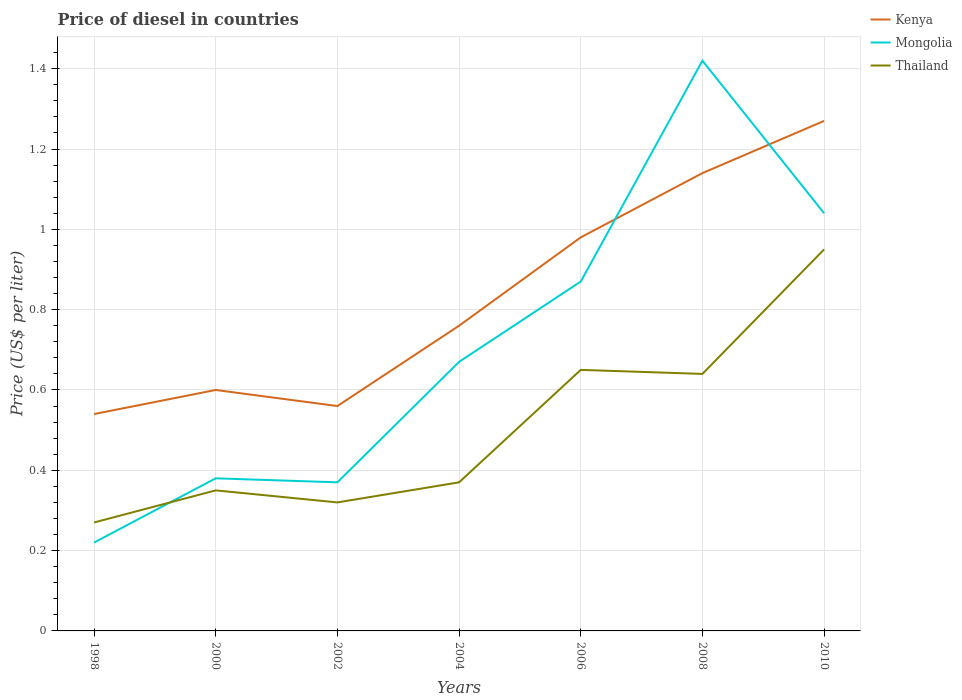How many different coloured lines are there?
Your answer should be very brief. 3. Does the line corresponding to Thailand intersect with the line corresponding to Mongolia?
Ensure brevity in your answer.  Yes. Is the number of lines equal to the number of legend labels?
Provide a succinct answer. Yes. Across all years, what is the maximum price of diesel in Thailand?
Your answer should be compact. 0.27. What is the total price of diesel in Kenya in the graph?
Make the answer very short. -0.58. What is the difference between the highest and the second highest price of diesel in Kenya?
Give a very brief answer. 0.73. How many lines are there?
Provide a short and direct response. 3. Are the values on the major ticks of Y-axis written in scientific E-notation?
Provide a succinct answer. No. Does the graph contain any zero values?
Ensure brevity in your answer.  No. What is the title of the graph?
Offer a terse response. Price of diesel in countries. What is the label or title of the X-axis?
Your answer should be very brief. Years. What is the label or title of the Y-axis?
Offer a very short reply. Price (US$ per liter). What is the Price (US$ per liter) of Kenya in 1998?
Offer a very short reply. 0.54. What is the Price (US$ per liter) in Mongolia in 1998?
Your answer should be very brief. 0.22. What is the Price (US$ per liter) of Thailand in 1998?
Keep it short and to the point. 0.27. What is the Price (US$ per liter) in Mongolia in 2000?
Give a very brief answer. 0.38. What is the Price (US$ per liter) in Kenya in 2002?
Make the answer very short. 0.56. What is the Price (US$ per liter) of Mongolia in 2002?
Keep it short and to the point. 0.37. What is the Price (US$ per liter) of Thailand in 2002?
Your response must be concise. 0.32. What is the Price (US$ per liter) in Kenya in 2004?
Offer a terse response. 0.76. What is the Price (US$ per liter) of Mongolia in 2004?
Your response must be concise. 0.67. What is the Price (US$ per liter) of Thailand in 2004?
Offer a very short reply. 0.37. What is the Price (US$ per liter) in Mongolia in 2006?
Offer a very short reply. 0.87. What is the Price (US$ per liter) of Thailand in 2006?
Your answer should be very brief. 0.65. What is the Price (US$ per liter) of Kenya in 2008?
Offer a very short reply. 1.14. What is the Price (US$ per liter) of Mongolia in 2008?
Your answer should be compact. 1.42. What is the Price (US$ per liter) of Thailand in 2008?
Make the answer very short. 0.64. What is the Price (US$ per liter) in Kenya in 2010?
Ensure brevity in your answer.  1.27. Across all years, what is the maximum Price (US$ per liter) in Kenya?
Ensure brevity in your answer.  1.27. Across all years, what is the maximum Price (US$ per liter) of Mongolia?
Your response must be concise. 1.42. Across all years, what is the maximum Price (US$ per liter) of Thailand?
Offer a terse response. 0.95. Across all years, what is the minimum Price (US$ per liter) in Kenya?
Your answer should be very brief. 0.54. Across all years, what is the minimum Price (US$ per liter) in Mongolia?
Offer a terse response. 0.22. Across all years, what is the minimum Price (US$ per liter) of Thailand?
Provide a short and direct response. 0.27. What is the total Price (US$ per liter) of Kenya in the graph?
Provide a short and direct response. 5.85. What is the total Price (US$ per liter) of Mongolia in the graph?
Keep it short and to the point. 4.97. What is the total Price (US$ per liter) in Thailand in the graph?
Provide a succinct answer. 3.55. What is the difference between the Price (US$ per liter) of Kenya in 1998 and that in 2000?
Provide a succinct answer. -0.06. What is the difference between the Price (US$ per liter) in Mongolia in 1998 and that in 2000?
Give a very brief answer. -0.16. What is the difference between the Price (US$ per liter) in Thailand in 1998 and that in 2000?
Offer a very short reply. -0.08. What is the difference between the Price (US$ per liter) of Kenya in 1998 and that in 2002?
Your response must be concise. -0.02. What is the difference between the Price (US$ per liter) in Thailand in 1998 and that in 2002?
Give a very brief answer. -0.05. What is the difference between the Price (US$ per liter) of Kenya in 1998 and that in 2004?
Your answer should be very brief. -0.22. What is the difference between the Price (US$ per liter) in Mongolia in 1998 and that in 2004?
Make the answer very short. -0.45. What is the difference between the Price (US$ per liter) in Thailand in 1998 and that in 2004?
Provide a succinct answer. -0.1. What is the difference between the Price (US$ per liter) of Kenya in 1998 and that in 2006?
Give a very brief answer. -0.44. What is the difference between the Price (US$ per liter) of Mongolia in 1998 and that in 2006?
Ensure brevity in your answer.  -0.65. What is the difference between the Price (US$ per liter) of Thailand in 1998 and that in 2006?
Your response must be concise. -0.38. What is the difference between the Price (US$ per liter) in Thailand in 1998 and that in 2008?
Your response must be concise. -0.37. What is the difference between the Price (US$ per liter) of Kenya in 1998 and that in 2010?
Keep it short and to the point. -0.73. What is the difference between the Price (US$ per liter) of Mongolia in 1998 and that in 2010?
Offer a terse response. -0.82. What is the difference between the Price (US$ per liter) of Thailand in 1998 and that in 2010?
Offer a very short reply. -0.68. What is the difference between the Price (US$ per liter) of Thailand in 2000 and that in 2002?
Give a very brief answer. 0.03. What is the difference between the Price (US$ per liter) in Kenya in 2000 and that in 2004?
Your answer should be compact. -0.16. What is the difference between the Price (US$ per liter) of Mongolia in 2000 and that in 2004?
Offer a terse response. -0.29. What is the difference between the Price (US$ per liter) in Thailand in 2000 and that in 2004?
Make the answer very short. -0.02. What is the difference between the Price (US$ per liter) of Kenya in 2000 and that in 2006?
Offer a very short reply. -0.38. What is the difference between the Price (US$ per liter) of Mongolia in 2000 and that in 2006?
Offer a very short reply. -0.49. What is the difference between the Price (US$ per liter) in Thailand in 2000 and that in 2006?
Provide a short and direct response. -0.3. What is the difference between the Price (US$ per liter) in Kenya in 2000 and that in 2008?
Your answer should be compact. -0.54. What is the difference between the Price (US$ per liter) in Mongolia in 2000 and that in 2008?
Your response must be concise. -1.04. What is the difference between the Price (US$ per liter) in Thailand in 2000 and that in 2008?
Your response must be concise. -0.29. What is the difference between the Price (US$ per liter) in Kenya in 2000 and that in 2010?
Provide a short and direct response. -0.67. What is the difference between the Price (US$ per liter) of Mongolia in 2000 and that in 2010?
Provide a short and direct response. -0.66. What is the difference between the Price (US$ per liter) of Kenya in 2002 and that in 2004?
Your answer should be very brief. -0.2. What is the difference between the Price (US$ per liter) of Thailand in 2002 and that in 2004?
Offer a terse response. -0.05. What is the difference between the Price (US$ per liter) in Kenya in 2002 and that in 2006?
Ensure brevity in your answer.  -0.42. What is the difference between the Price (US$ per liter) of Thailand in 2002 and that in 2006?
Give a very brief answer. -0.33. What is the difference between the Price (US$ per liter) in Kenya in 2002 and that in 2008?
Your response must be concise. -0.58. What is the difference between the Price (US$ per liter) in Mongolia in 2002 and that in 2008?
Your answer should be very brief. -1.05. What is the difference between the Price (US$ per liter) of Thailand in 2002 and that in 2008?
Offer a very short reply. -0.32. What is the difference between the Price (US$ per liter) of Kenya in 2002 and that in 2010?
Your answer should be compact. -0.71. What is the difference between the Price (US$ per liter) of Mongolia in 2002 and that in 2010?
Give a very brief answer. -0.67. What is the difference between the Price (US$ per liter) in Thailand in 2002 and that in 2010?
Offer a terse response. -0.63. What is the difference between the Price (US$ per liter) of Kenya in 2004 and that in 2006?
Keep it short and to the point. -0.22. What is the difference between the Price (US$ per liter) of Thailand in 2004 and that in 2006?
Your answer should be compact. -0.28. What is the difference between the Price (US$ per liter) in Kenya in 2004 and that in 2008?
Make the answer very short. -0.38. What is the difference between the Price (US$ per liter) in Mongolia in 2004 and that in 2008?
Provide a succinct answer. -0.75. What is the difference between the Price (US$ per liter) in Thailand in 2004 and that in 2008?
Give a very brief answer. -0.27. What is the difference between the Price (US$ per liter) in Kenya in 2004 and that in 2010?
Your answer should be very brief. -0.51. What is the difference between the Price (US$ per liter) in Mongolia in 2004 and that in 2010?
Your answer should be compact. -0.37. What is the difference between the Price (US$ per liter) in Thailand in 2004 and that in 2010?
Keep it short and to the point. -0.58. What is the difference between the Price (US$ per liter) of Kenya in 2006 and that in 2008?
Provide a succinct answer. -0.16. What is the difference between the Price (US$ per liter) in Mongolia in 2006 and that in 2008?
Your response must be concise. -0.55. What is the difference between the Price (US$ per liter) in Kenya in 2006 and that in 2010?
Your response must be concise. -0.29. What is the difference between the Price (US$ per liter) in Mongolia in 2006 and that in 2010?
Keep it short and to the point. -0.17. What is the difference between the Price (US$ per liter) of Thailand in 2006 and that in 2010?
Provide a short and direct response. -0.3. What is the difference between the Price (US$ per liter) in Kenya in 2008 and that in 2010?
Keep it short and to the point. -0.13. What is the difference between the Price (US$ per liter) of Mongolia in 2008 and that in 2010?
Offer a terse response. 0.38. What is the difference between the Price (US$ per liter) of Thailand in 2008 and that in 2010?
Give a very brief answer. -0.31. What is the difference between the Price (US$ per liter) in Kenya in 1998 and the Price (US$ per liter) in Mongolia in 2000?
Provide a succinct answer. 0.16. What is the difference between the Price (US$ per liter) of Kenya in 1998 and the Price (US$ per liter) of Thailand in 2000?
Provide a short and direct response. 0.19. What is the difference between the Price (US$ per liter) in Mongolia in 1998 and the Price (US$ per liter) in Thailand in 2000?
Keep it short and to the point. -0.13. What is the difference between the Price (US$ per liter) of Kenya in 1998 and the Price (US$ per liter) of Mongolia in 2002?
Provide a short and direct response. 0.17. What is the difference between the Price (US$ per liter) in Kenya in 1998 and the Price (US$ per liter) in Thailand in 2002?
Keep it short and to the point. 0.22. What is the difference between the Price (US$ per liter) in Mongolia in 1998 and the Price (US$ per liter) in Thailand in 2002?
Ensure brevity in your answer.  -0.1. What is the difference between the Price (US$ per liter) in Kenya in 1998 and the Price (US$ per liter) in Mongolia in 2004?
Your answer should be very brief. -0.13. What is the difference between the Price (US$ per liter) of Kenya in 1998 and the Price (US$ per liter) of Thailand in 2004?
Offer a terse response. 0.17. What is the difference between the Price (US$ per liter) of Mongolia in 1998 and the Price (US$ per liter) of Thailand in 2004?
Ensure brevity in your answer.  -0.15. What is the difference between the Price (US$ per liter) of Kenya in 1998 and the Price (US$ per liter) of Mongolia in 2006?
Provide a succinct answer. -0.33. What is the difference between the Price (US$ per liter) of Kenya in 1998 and the Price (US$ per liter) of Thailand in 2006?
Your answer should be compact. -0.11. What is the difference between the Price (US$ per liter) of Mongolia in 1998 and the Price (US$ per liter) of Thailand in 2006?
Your answer should be very brief. -0.43. What is the difference between the Price (US$ per liter) in Kenya in 1998 and the Price (US$ per liter) in Mongolia in 2008?
Make the answer very short. -0.88. What is the difference between the Price (US$ per liter) in Kenya in 1998 and the Price (US$ per liter) in Thailand in 2008?
Offer a terse response. -0.1. What is the difference between the Price (US$ per liter) of Mongolia in 1998 and the Price (US$ per liter) of Thailand in 2008?
Your answer should be compact. -0.42. What is the difference between the Price (US$ per liter) of Kenya in 1998 and the Price (US$ per liter) of Thailand in 2010?
Give a very brief answer. -0.41. What is the difference between the Price (US$ per liter) in Mongolia in 1998 and the Price (US$ per liter) in Thailand in 2010?
Ensure brevity in your answer.  -0.73. What is the difference between the Price (US$ per liter) in Kenya in 2000 and the Price (US$ per liter) in Mongolia in 2002?
Your response must be concise. 0.23. What is the difference between the Price (US$ per liter) in Kenya in 2000 and the Price (US$ per liter) in Thailand in 2002?
Provide a short and direct response. 0.28. What is the difference between the Price (US$ per liter) of Mongolia in 2000 and the Price (US$ per liter) of Thailand in 2002?
Offer a very short reply. 0.06. What is the difference between the Price (US$ per liter) of Kenya in 2000 and the Price (US$ per liter) of Mongolia in 2004?
Your response must be concise. -0.07. What is the difference between the Price (US$ per liter) of Kenya in 2000 and the Price (US$ per liter) of Thailand in 2004?
Keep it short and to the point. 0.23. What is the difference between the Price (US$ per liter) of Mongolia in 2000 and the Price (US$ per liter) of Thailand in 2004?
Provide a short and direct response. 0.01. What is the difference between the Price (US$ per liter) in Kenya in 2000 and the Price (US$ per liter) in Mongolia in 2006?
Make the answer very short. -0.27. What is the difference between the Price (US$ per liter) of Mongolia in 2000 and the Price (US$ per liter) of Thailand in 2006?
Ensure brevity in your answer.  -0.27. What is the difference between the Price (US$ per liter) of Kenya in 2000 and the Price (US$ per liter) of Mongolia in 2008?
Your answer should be very brief. -0.82. What is the difference between the Price (US$ per liter) of Kenya in 2000 and the Price (US$ per liter) of Thailand in 2008?
Your answer should be compact. -0.04. What is the difference between the Price (US$ per liter) of Mongolia in 2000 and the Price (US$ per liter) of Thailand in 2008?
Provide a succinct answer. -0.26. What is the difference between the Price (US$ per liter) in Kenya in 2000 and the Price (US$ per liter) in Mongolia in 2010?
Your answer should be very brief. -0.44. What is the difference between the Price (US$ per liter) of Kenya in 2000 and the Price (US$ per liter) of Thailand in 2010?
Give a very brief answer. -0.35. What is the difference between the Price (US$ per liter) of Mongolia in 2000 and the Price (US$ per liter) of Thailand in 2010?
Offer a very short reply. -0.57. What is the difference between the Price (US$ per liter) of Kenya in 2002 and the Price (US$ per liter) of Mongolia in 2004?
Offer a very short reply. -0.11. What is the difference between the Price (US$ per liter) of Kenya in 2002 and the Price (US$ per liter) of Thailand in 2004?
Your response must be concise. 0.19. What is the difference between the Price (US$ per liter) in Kenya in 2002 and the Price (US$ per liter) in Mongolia in 2006?
Provide a short and direct response. -0.31. What is the difference between the Price (US$ per liter) in Kenya in 2002 and the Price (US$ per liter) in Thailand in 2006?
Your answer should be compact. -0.09. What is the difference between the Price (US$ per liter) in Mongolia in 2002 and the Price (US$ per liter) in Thailand in 2006?
Keep it short and to the point. -0.28. What is the difference between the Price (US$ per liter) in Kenya in 2002 and the Price (US$ per liter) in Mongolia in 2008?
Keep it short and to the point. -0.86. What is the difference between the Price (US$ per liter) in Kenya in 2002 and the Price (US$ per liter) in Thailand in 2008?
Provide a succinct answer. -0.08. What is the difference between the Price (US$ per liter) in Mongolia in 2002 and the Price (US$ per liter) in Thailand in 2008?
Your response must be concise. -0.27. What is the difference between the Price (US$ per liter) of Kenya in 2002 and the Price (US$ per liter) of Mongolia in 2010?
Ensure brevity in your answer.  -0.48. What is the difference between the Price (US$ per liter) in Kenya in 2002 and the Price (US$ per liter) in Thailand in 2010?
Your answer should be compact. -0.39. What is the difference between the Price (US$ per liter) of Mongolia in 2002 and the Price (US$ per liter) of Thailand in 2010?
Keep it short and to the point. -0.58. What is the difference between the Price (US$ per liter) of Kenya in 2004 and the Price (US$ per liter) of Mongolia in 2006?
Ensure brevity in your answer.  -0.11. What is the difference between the Price (US$ per liter) in Kenya in 2004 and the Price (US$ per liter) in Thailand in 2006?
Offer a terse response. 0.11. What is the difference between the Price (US$ per liter) in Kenya in 2004 and the Price (US$ per liter) in Mongolia in 2008?
Offer a terse response. -0.66. What is the difference between the Price (US$ per liter) of Kenya in 2004 and the Price (US$ per liter) of Thailand in 2008?
Provide a short and direct response. 0.12. What is the difference between the Price (US$ per liter) in Kenya in 2004 and the Price (US$ per liter) in Mongolia in 2010?
Your answer should be compact. -0.28. What is the difference between the Price (US$ per liter) in Kenya in 2004 and the Price (US$ per liter) in Thailand in 2010?
Your response must be concise. -0.19. What is the difference between the Price (US$ per liter) in Mongolia in 2004 and the Price (US$ per liter) in Thailand in 2010?
Your answer should be very brief. -0.28. What is the difference between the Price (US$ per liter) of Kenya in 2006 and the Price (US$ per liter) of Mongolia in 2008?
Your answer should be very brief. -0.44. What is the difference between the Price (US$ per liter) of Kenya in 2006 and the Price (US$ per liter) of Thailand in 2008?
Your response must be concise. 0.34. What is the difference between the Price (US$ per liter) of Mongolia in 2006 and the Price (US$ per liter) of Thailand in 2008?
Offer a terse response. 0.23. What is the difference between the Price (US$ per liter) in Kenya in 2006 and the Price (US$ per liter) in Mongolia in 2010?
Ensure brevity in your answer.  -0.06. What is the difference between the Price (US$ per liter) in Mongolia in 2006 and the Price (US$ per liter) in Thailand in 2010?
Keep it short and to the point. -0.08. What is the difference between the Price (US$ per liter) of Kenya in 2008 and the Price (US$ per liter) of Thailand in 2010?
Provide a succinct answer. 0.19. What is the difference between the Price (US$ per liter) of Mongolia in 2008 and the Price (US$ per liter) of Thailand in 2010?
Your answer should be very brief. 0.47. What is the average Price (US$ per liter) of Kenya per year?
Keep it short and to the point. 0.84. What is the average Price (US$ per liter) in Mongolia per year?
Keep it short and to the point. 0.71. What is the average Price (US$ per liter) of Thailand per year?
Provide a succinct answer. 0.51. In the year 1998, what is the difference between the Price (US$ per liter) of Kenya and Price (US$ per liter) of Mongolia?
Make the answer very short. 0.32. In the year 1998, what is the difference between the Price (US$ per liter) of Kenya and Price (US$ per liter) of Thailand?
Offer a very short reply. 0.27. In the year 2000, what is the difference between the Price (US$ per liter) of Kenya and Price (US$ per liter) of Mongolia?
Your response must be concise. 0.22. In the year 2000, what is the difference between the Price (US$ per liter) in Mongolia and Price (US$ per liter) in Thailand?
Your answer should be compact. 0.03. In the year 2002, what is the difference between the Price (US$ per liter) of Kenya and Price (US$ per liter) of Mongolia?
Ensure brevity in your answer.  0.19. In the year 2002, what is the difference between the Price (US$ per liter) in Kenya and Price (US$ per liter) in Thailand?
Make the answer very short. 0.24. In the year 2004, what is the difference between the Price (US$ per liter) of Kenya and Price (US$ per liter) of Mongolia?
Keep it short and to the point. 0.09. In the year 2004, what is the difference between the Price (US$ per liter) in Kenya and Price (US$ per liter) in Thailand?
Give a very brief answer. 0.39. In the year 2006, what is the difference between the Price (US$ per liter) in Kenya and Price (US$ per liter) in Mongolia?
Ensure brevity in your answer.  0.11. In the year 2006, what is the difference between the Price (US$ per liter) in Kenya and Price (US$ per liter) in Thailand?
Your answer should be compact. 0.33. In the year 2006, what is the difference between the Price (US$ per liter) in Mongolia and Price (US$ per liter) in Thailand?
Keep it short and to the point. 0.22. In the year 2008, what is the difference between the Price (US$ per liter) of Kenya and Price (US$ per liter) of Mongolia?
Provide a short and direct response. -0.28. In the year 2008, what is the difference between the Price (US$ per liter) in Kenya and Price (US$ per liter) in Thailand?
Provide a succinct answer. 0.5. In the year 2008, what is the difference between the Price (US$ per liter) in Mongolia and Price (US$ per liter) in Thailand?
Provide a succinct answer. 0.78. In the year 2010, what is the difference between the Price (US$ per liter) of Kenya and Price (US$ per liter) of Mongolia?
Offer a terse response. 0.23. In the year 2010, what is the difference between the Price (US$ per liter) of Kenya and Price (US$ per liter) of Thailand?
Your answer should be compact. 0.32. In the year 2010, what is the difference between the Price (US$ per liter) of Mongolia and Price (US$ per liter) of Thailand?
Your answer should be compact. 0.09. What is the ratio of the Price (US$ per liter) of Kenya in 1998 to that in 2000?
Give a very brief answer. 0.9. What is the ratio of the Price (US$ per liter) in Mongolia in 1998 to that in 2000?
Your answer should be very brief. 0.58. What is the ratio of the Price (US$ per liter) of Thailand in 1998 to that in 2000?
Ensure brevity in your answer.  0.77. What is the ratio of the Price (US$ per liter) in Kenya in 1998 to that in 2002?
Your answer should be compact. 0.96. What is the ratio of the Price (US$ per liter) in Mongolia in 1998 to that in 2002?
Give a very brief answer. 0.59. What is the ratio of the Price (US$ per liter) of Thailand in 1998 to that in 2002?
Give a very brief answer. 0.84. What is the ratio of the Price (US$ per liter) of Kenya in 1998 to that in 2004?
Offer a terse response. 0.71. What is the ratio of the Price (US$ per liter) in Mongolia in 1998 to that in 2004?
Ensure brevity in your answer.  0.33. What is the ratio of the Price (US$ per liter) of Thailand in 1998 to that in 2004?
Offer a terse response. 0.73. What is the ratio of the Price (US$ per liter) of Kenya in 1998 to that in 2006?
Keep it short and to the point. 0.55. What is the ratio of the Price (US$ per liter) of Mongolia in 1998 to that in 2006?
Offer a terse response. 0.25. What is the ratio of the Price (US$ per liter) in Thailand in 1998 to that in 2006?
Provide a short and direct response. 0.42. What is the ratio of the Price (US$ per liter) in Kenya in 1998 to that in 2008?
Keep it short and to the point. 0.47. What is the ratio of the Price (US$ per liter) of Mongolia in 1998 to that in 2008?
Provide a succinct answer. 0.15. What is the ratio of the Price (US$ per liter) in Thailand in 1998 to that in 2008?
Your answer should be compact. 0.42. What is the ratio of the Price (US$ per liter) in Kenya in 1998 to that in 2010?
Your answer should be compact. 0.43. What is the ratio of the Price (US$ per liter) in Mongolia in 1998 to that in 2010?
Your response must be concise. 0.21. What is the ratio of the Price (US$ per liter) in Thailand in 1998 to that in 2010?
Offer a very short reply. 0.28. What is the ratio of the Price (US$ per liter) of Kenya in 2000 to that in 2002?
Provide a succinct answer. 1.07. What is the ratio of the Price (US$ per liter) of Thailand in 2000 to that in 2002?
Your answer should be very brief. 1.09. What is the ratio of the Price (US$ per liter) of Kenya in 2000 to that in 2004?
Ensure brevity in your answer.  0.79. What is the ratio of the Price (US$ per liter) in Mongolia in 2000 to that in 2004?
Ensure brevity in your answer.  0.57. What is the ratio of the Price (US$ per liter) of Thailand in 2000 to that in 2004?
Your response must be concise. 0.95. What is the ratio of the Price (US$ per liter) in Kenya in 2000 to that in 2006?
Offer a very short reply. 0.61. What is the ratio of the Price (US$ per liter) of Mongolia in 2000 to that in 2006?
Offer a very short reply. 0.44. What is the ratio of the Price (US$ per liter) in Thailand in 2000 to that in 2006?
Offer a very short reply. 0.54. What is the ratio of the Price (US$ per liter) of Kenya in 2000 to that in 2008?
Offer a terse response. 0.53. What is the ratio of the Price (US$ per liter) in Mongolia in 2000 to that in 2008?
Your answer should be very brief. 0.27. What is the ratio of the Price (US$ per liter) of Thailand in 2000 to that in 2008?
Your answer should be compact. 0.55. What is the ratio of the Price (US$ per liter) of Kenya in 2000 to that in 2010?
Keep it short and to the point. 0.47. What is the ratio of the Price (US$ per liter) in Mongolia in 2000 to that in 2010?
Give a very brief answer. 0.37. What is the ratio of the Price (US$ per liter) of Thailand in 2000 to that in 2010?
Offer a very short reply. 0.37. What is the ratio of the Price (US$ per liter) of Kenya in 2002 to that in 2004?
Give a very brief answer. 0.74. What is the ratio of the Price (US$ per liter) in Mongolia in 2002 to that in 2004?
Make the answer very short. 0.55. What is the ratio of the Price (US$ per liter) of Thailand in 2002 to that in 2004?
Give a very brief answer. 0.86. What is the ratio of the Price (US$ per liter) of Kenya in 2002 to that in 2006?
Offer a terse response. 0.57. What is the ratio of the Price (US$ per liter) of Mongolia in 2002 to that in 2006?
Give a very brief answer. 0.43. What is the ratio of the Price (US$ per liter) of Thailand in 2002 to that in 2006?
Offer a terse response. 0.49. What is the ratio of the Price (US$ per liter) of Kenya in 2002 to that in 2008?
Your response must be concise. 0.49. What is the ratio of the Price (US$ per liter) in Mongolia in 2002 to that in 2008?
Ensure brevity in your answer.  0.26. What is the ratio of the Price (US$ per liter) of Thailand in 2002 to that in 2008?
Your answer should be very brief. 0.5. What is the ratio of the Price (US$ per liter) in Kenya in 2002 to that in 2010?
Provide a short and direct response. 0.44. What is the ratio of the Price (US$ per liter) in Mongolia in 2002 to that in 2010?
Provide a short and direct response. 0.36. What is the ratio of the Price (US$ per liter) in Thailand in 2002 to that in 2010?
Offer a very short reply. 0.34. What is the ratio of the Price (US$ per liter) of Kenya in 2004 to that in 2006?
Your answer should be compact. 0.78. What is the ratio of the Price (US$ per liter) in Mongolia in 2004 to that in 2006?
Your answer should be compact. 0.77. What is the ratio of the Price (US$ per liter) of Thailand in 2004 to that in 2006?
Keep it short and to the point. 0.57. What is the ratio of the Price (US$ per liter) in Kenya in 2004 to that in 2008?
Your answer should be very brief. 0.67. What is the ratio of the Price (US$ per liter) of Mongolia in 2004 to that in 2008?
Offer a very short reply. 0.47. What is the ratio of the Price (US$ per liter) of Thailand in 2004 to that in 2008?
Make the answer very short. 0.58. What is the ratio of the Price (US$ per liter) in Kenya in 2004 to that in 2010?
Make the answer very short. 0.6. What is the ratio of the Price (US$ per liter) of Mongolia in 2004 to that in 2010?
Your answer should be compact. 0.64. What is the ratio of the Price (US$ per liter) of Thailand in 2004 to that in 2010?
Ensure brevity in your answer.  0.39. What is the ratio of the Price (US$ per liter) of Kenya in 2006 to that in 2008?
Your response must be concise. 0.86. What is the ratio of the Price (US$ per liter) in Mongolia in 2006 to that in 2008?
Make the answer very short. 0.61. What is the ratio of the Price (US$ per liter) of Thailand in 2006 to that in 2008?
Your response must be concise. 1.02. What is the ratio of the Price (US$ per liter) in Kenya in 2006 to that in 2010?
Provide a short and direct response. 0.77. What is the ratio of the Price (US$ per liter) of Mongolia in 2006 to that in 2010?
Provide a short and direct response. 0.84. What is the ratio of the Price (US$ per liter) in Thailand in 2006 to that in 2010?
Provide a short and direct response. 0.68. What is the ratio of the Price (US$ per liter) of Kenya in 2008 to that in 2010?
Keep it short and to the point. 0.9. What is the ratio of the Price (US$ per liter) in Mongolia in 2008 to that in 2010?
Give a very brief answer. 1.37. What is the ratio of the Price (US$ per liter) of Thailand in 2008 to that in 2010?
Ensure brevity in your answer.  0.67. What is the difference between the highest and the second highest Price (US$ per liter) of Kenya?
Make the answer very short. 0.13. What is the difference between the highest and the second highest Price (US$ per liter) in Mongolia?
Ensure brevity in your answer.  0.38. What is the difference between the highest and the lowest Price (US$ per liter) in Kenya?
Your response must be concise. 0.73. What is the difference between the highest and the lowest Price (US$ per liter) of Mongolia?
Offer a terse response. 1.2. What is the difference between the highest and the lowest Price (US$ per liter) in Thailand?
Your answer should be very brief. 0.68. 